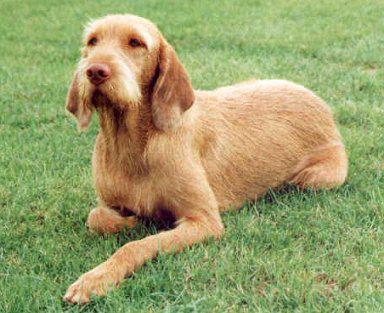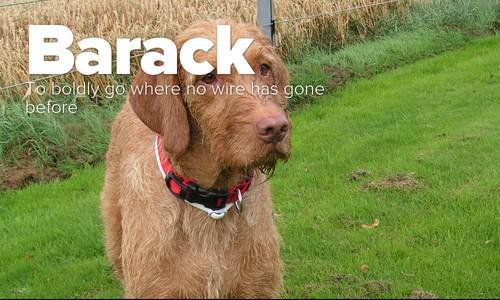The first image is the image on the left, the second image is the image on the right. For the images displayed, is the sentence "In one image, a dog is carrying a stuffed animal in its mouth." factually correct? Answer yes or no. No. 